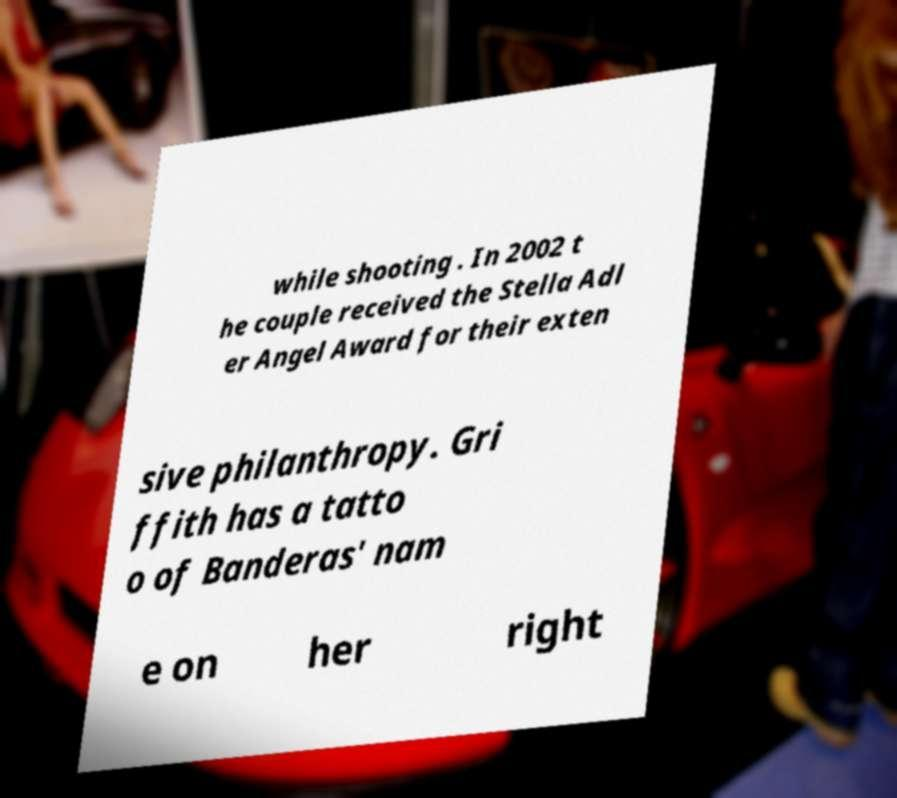What messages or text are displayed in this image? I need them in a readable, typed format. while shooting . In 2002 t he couple received the Stella Adl er Angel Award for their exten sive philanthropy. Gri ffith has a tatto o of Banderas' nam e on her right 